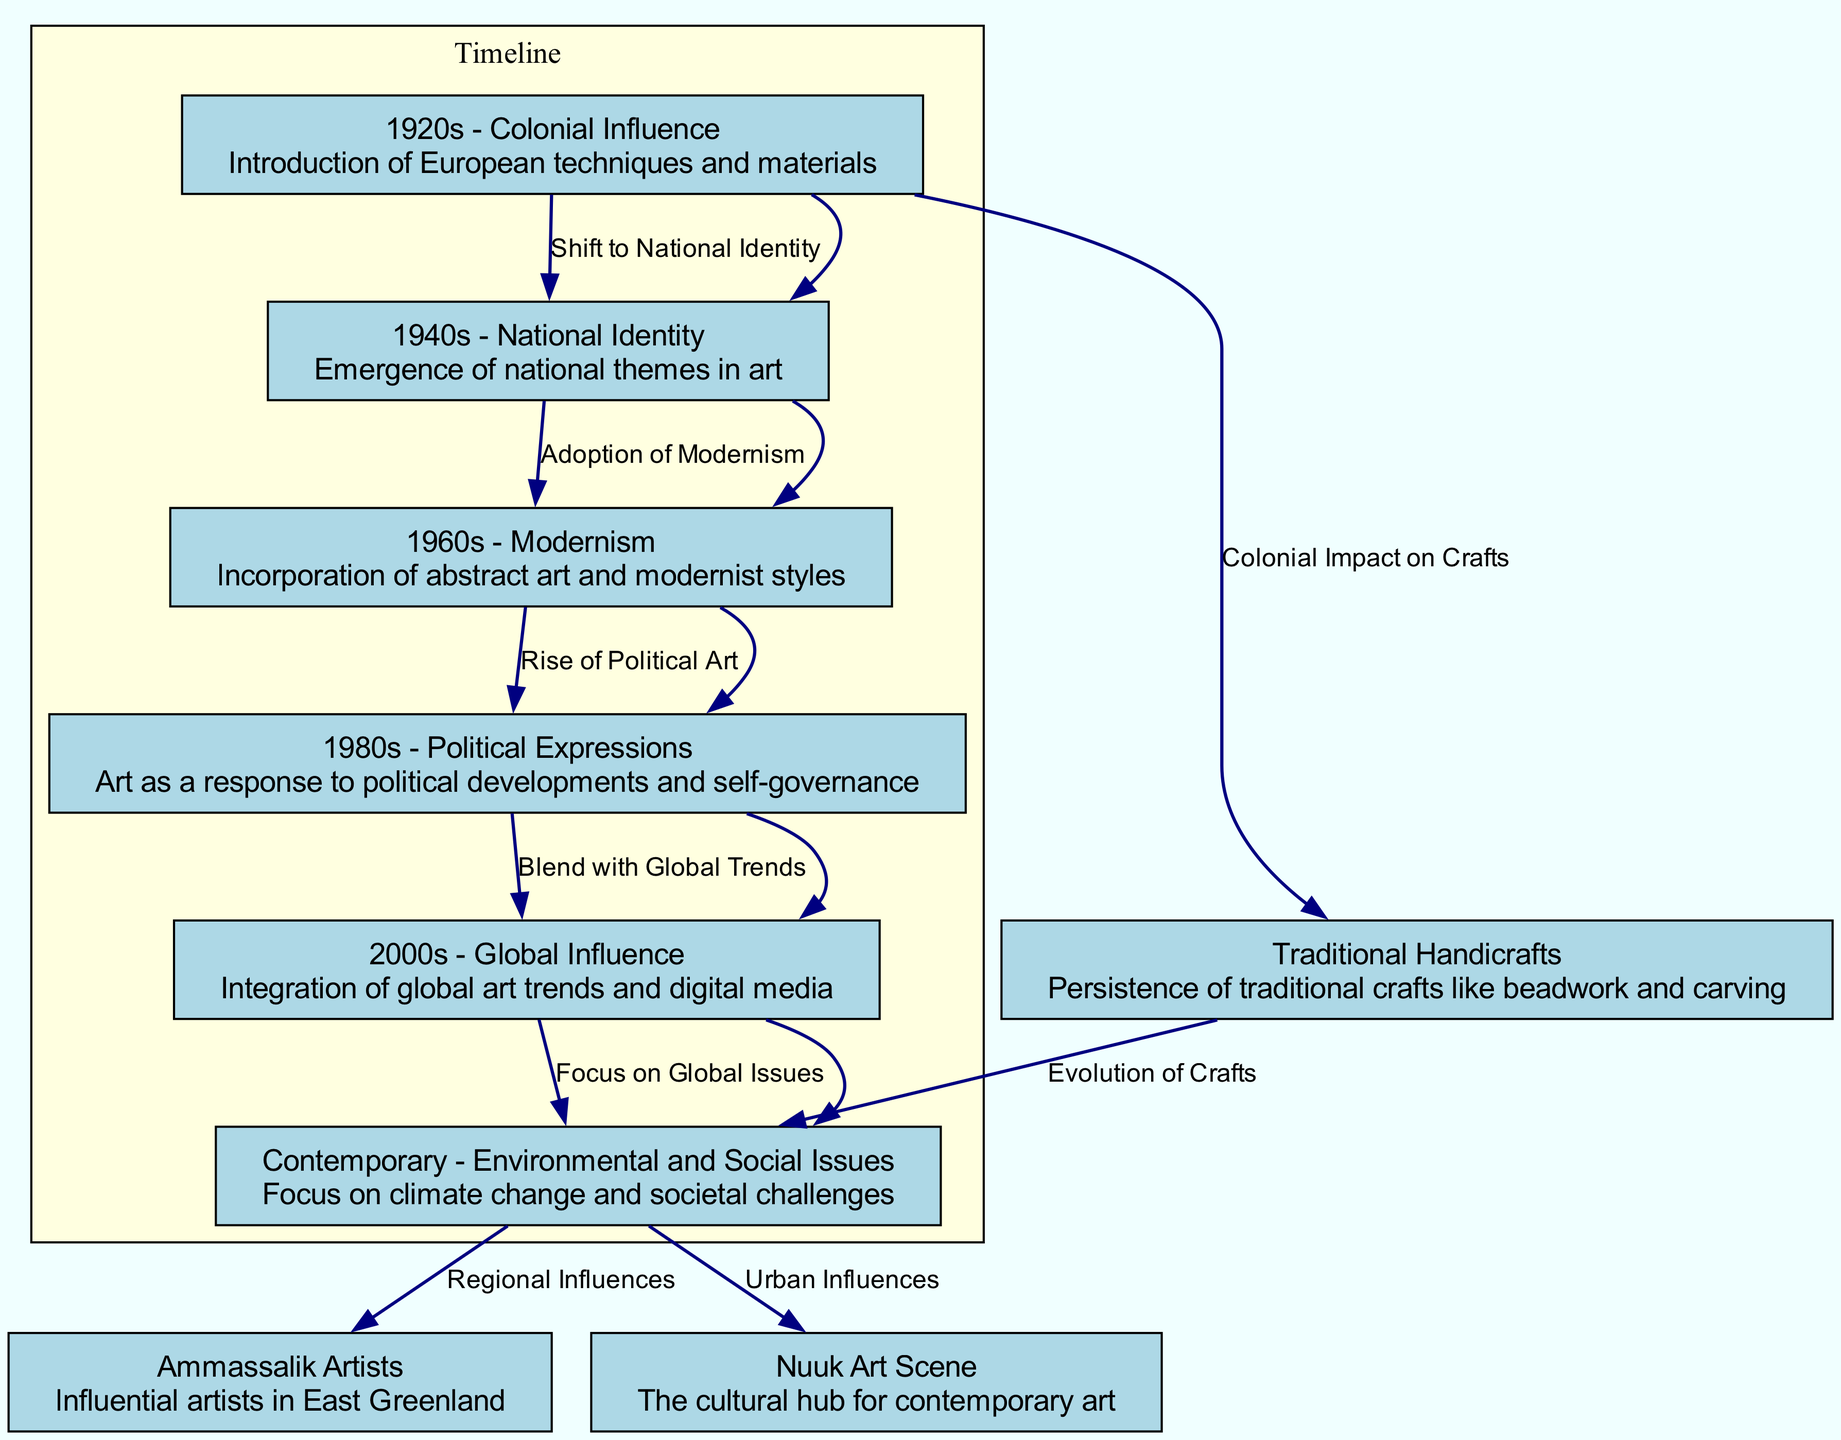What is the starting point of the timeline represented in the diagram? The diagram indicates that the starting point of the timeline is the "1920s - Colonial Influence," which introduces European techniques into Greenlandic arts.
Answer: 1920s - Colonial Influence What node follows the "1940s - National Identity" in the timeline? According to the diagram, the node that follows "1940s - National Identity" is "1960s - Modernism," which signifies a period of embracing abstract art styles.
Answer: 1960s - Modernism How many edges are there in total in the diagram? By counting each connection (edge) between the nodes, the total number of edges in the diagram is eight, indicating the various relationships among different art periods and influences.
Answer: 8 What influence is described in the 2000s node? The 2000s node focuses on the integration of global art trends and digital media along with influences from contemporary practices worldwide, highlighting a broader connection to the global art landscape.
Answer: Global Influence Which two regional influences are represented in the contemporary node? The contemporary node cites two regional influences: "Ammassalik" and "Nuuk," which signify important cultural hubs for Greenlandic art based on geographic and urban considerations.
Answer: Ammassalik and Nuuk What label connects the "1960s - Modernism" to the "1980s - Political Expressions"? The connecting label between these two nodes is "Rise of Political Art," illustrating a shift where modern artistic expressions began responding to political contexts and social issues.
Answer: Rise of Political Art What type of art does the "Handicrafts" node indicate? The "Handicrafts" node refers to traditional crafts such as beadwork and carving, showing the enduring nature of these practices despite the influence of modern techniques.
Answer: Traditional Handicrafts Which decade marks the emergence of national themes in art? The "1940s - National Identity" marks the decade where national themes start to become prominent in Greenlandic art, indicating a cultural shift towards self-identification.
Answer: 1940s - National Identity What does the contemporary node focus on regarding current issues? The contemporary node focuses on "Environmental and Social Issues," reflecting the prioritization of pressing topics like climate change and societal challenges in current art practices.
Answer: Environmental and Social Issues 